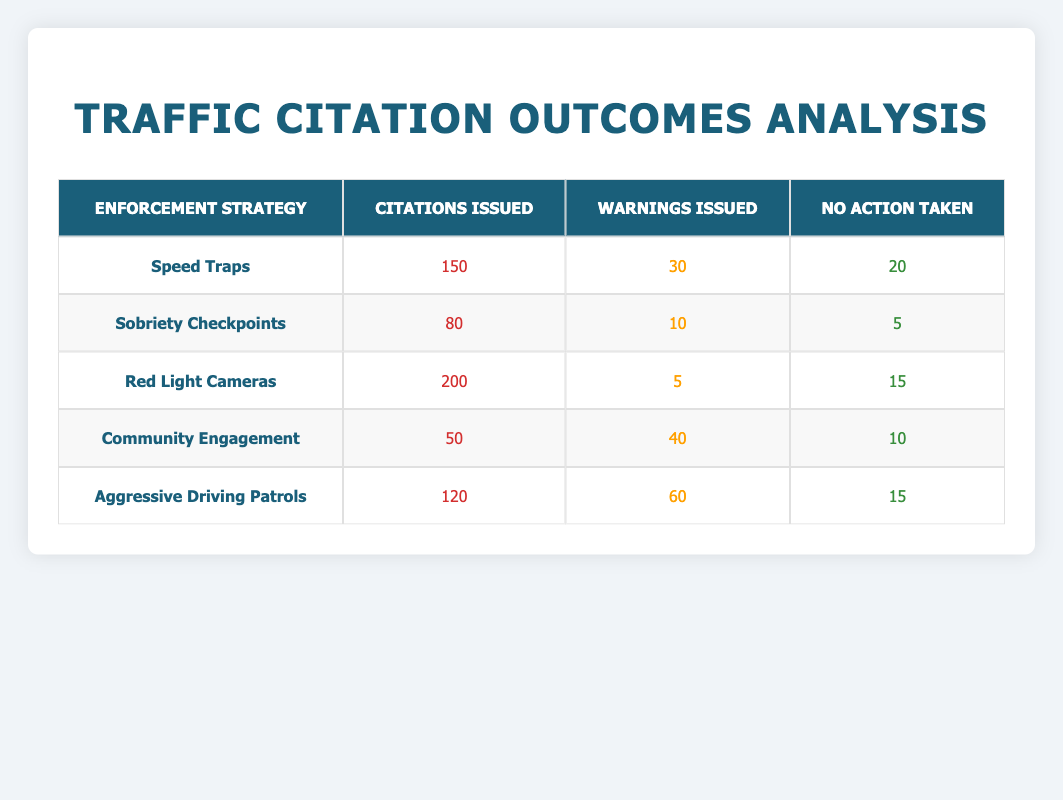What enforcement strategy issued the most citations? By examining the "Citations Issued" column, we see that the "Red Light Cameras" strategy has the highest value of 200 citations, which is more than any other strategy listed.
Answer: Red Light Cameras How many warnings were issued by the Aggressive Driving Patrols? The table indicates that the "Aggressive Driving Patrols" strategy resulted in 60 warnings issued, which is clearly stated in the corresponding row of the table.
Answer: 60 Which enforcement strategy had the fewest citations issued? In the "Citations Issued" column, the "Community Engagement" strategy has the lowest value of 50 citations when compared to the other strategies listed.
Answer: Community Engagement What is the total number of warnings issued across all strategies? To find the total number of warnings, we sum the values from the "Warnings Issued" column: 30 + 10 + 5 + 40 + 60 = 145. This sum gives us the cumulative number of warnings issued by all strategies.
Answer: 145 Did the Sobriety Checkpoints strategy have more citations issued than Community Engagement? Comparing the values, Sobriety Checkpoints has 80 citations while Community Engagement has only 50. Therefore, Sobriety Checkpoints did indeed have more citations issued.
Answer: Yes What percentage of citations issued were from Red Light Cameras compared to the total citations issued across all strategies? First, we calculate the total citations: 150 + 80 + 200 + 50 + 120 = 600. Next, we find the percentage from Red Light Cameras: (200 / 600) * 100 = 33.33%. Thus, Red Light Cameras issued 33.33% of the total citations.
Answer: 33.33% Which strategy had the highest ratio of warnings to citations issued? The ratio for each strategy can be calculated as follows: Speed Traps (30/150 = 0.2), Sobriety Checkpoints (10/80 = 0.125), Red Light Cameras (5/200 = 0.025), Community Engagement (40/50 = 0.8), Aggressive Driving Patrols (60/120 = 0.5). The highest ratio is from Community Engagement, with a ratio of 0.8.
Answer: Community Engagement How many total actions (citations, warnings, and no actions) were taken for Red Light Cameras? For Red Light Cameras, we add all outcomes: Citations (200) + Warnings (5) + No Action Taken (15) = 220 total actions. This shows the total responses for that enforcement strategy.
Answer: 220 If you were to choose between Speed Traps and Aggressive Driving Patrols based solely on the citations issued, which would you prefer? Speed Traps issued 150 citations while Aggressive Driving Patrols issued 120 citations. Since Speed Traps issued more citations, it would be the preferred choice based purely on the number of citations.
Answer: Speed Traps 